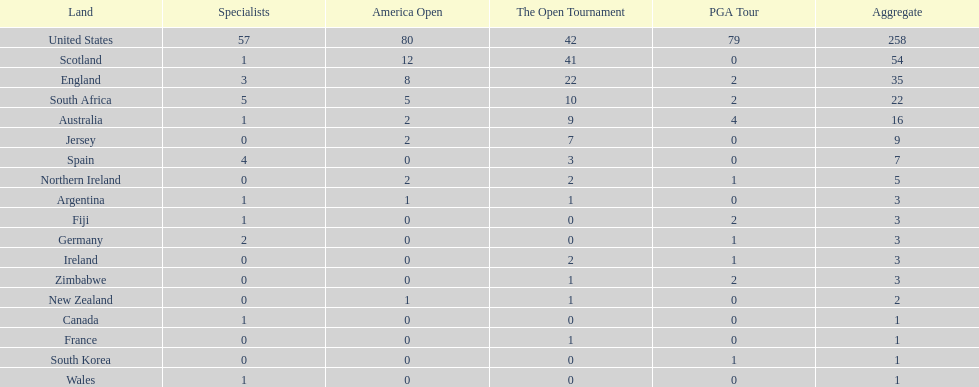How many total championships does spain have? 7. 